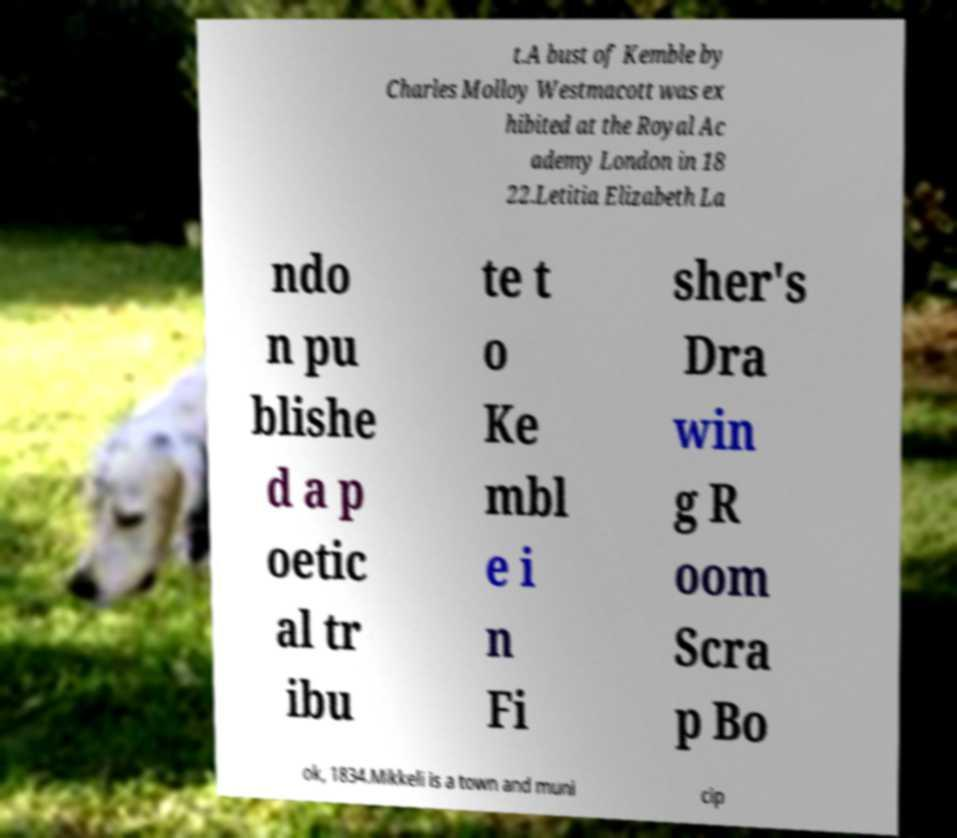Could you assist in decoding the text presented in this image and type it out clearly? t.A bust of Kemble by Charles Molloy Westmacott was ex hibited at the Royal Ac ademy London in 18 22.Letitia Elizabeth La ndo n pu blishe d a p oetic al tr ibu te t o Ke mbl e i n Fi sher's Dra win g R oom Scra p Bo ok, 1834.Mikkeli is a town and muni cip 